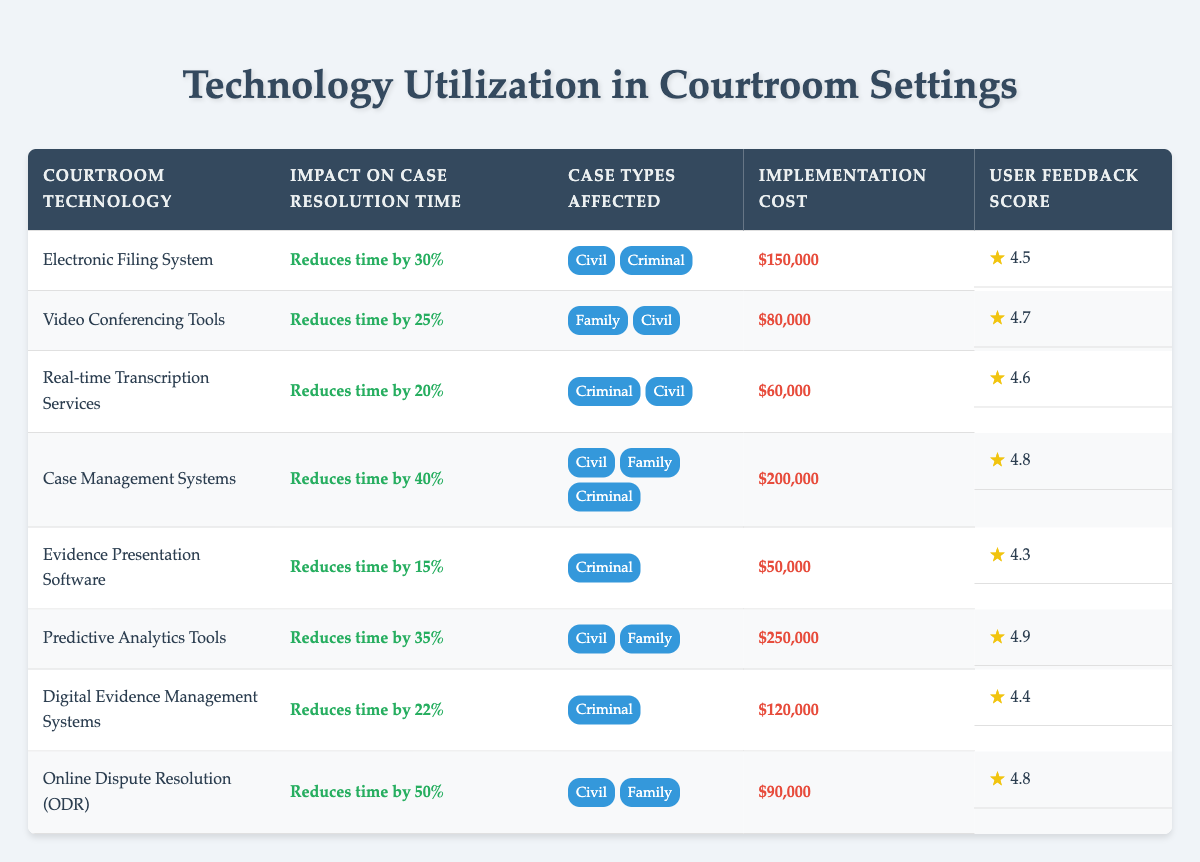What is the impact on case resolution time for the Case Management Systems? The table indicates that Case Management Systems reduce case resolution time by 40%. This information can be found in the column titled "Impact on Case Resolution Time" for the respective technology.
Answer: 40% Which courtroom technology has the highest user feedback score? By examining the "User Feedback Score" column, Predictive Analytics Tools has the highest score of 4.9. This is compared against all other technologies listed in the table to determine which one has the highest score.
Answer: 4.9 How much does it cost to implement the Evidence Presentation Software? The "Implementation Cost" column specifies that the cost to implement Evidence Presentation Software is $50,000, which is directly stated next to that technology in the table.
Answer: $50,000 Which case types are affected by the Online Dispute Resolution (ODR)? The table shows that Online Dispute Resolution (ODR) affects the case types Civil and Family. This can be referenced in the "Case Types Affected" column for that specific technology.
Answer: Civil, Family Is the implementation cost for Digital Evidence Management Systems greater than the average of all implementation costs? To find the average, sum the implementation costs of all technologies: $150,000 + $80,000 + $60,000 + $200,000 + $50,000 + $250,000 + $120,000 + $90,000 = $1,000,000. There are 8 technologies in total, so the average cost is $1,000,000 / 8 = $125,000. Since Digital Evidence Management Systems cost $120,000, which is less than the average of $125,000, the answer is no.
Answer: No Which two technologies together provide a reduction in case resolution time of over 60%? Looking at the impact reductions: Case Management Systems (40%) and Online Dispute Resolution (ODR) (50%) combine for a total of 90% reduction in case resolution time (40% + 50% = 90%). Since this exceeds 60%, these two technologies fulfill the criteria.
Answer: Case Management Systems and Online Dispute Resolution What is the total time reduction from using the Predictive Analytics Tools, Real-time Transcription Services, and Video Conferencing Tools? Summing the time reductions for these technologies: Predictive Analytics Tools (35%) + Real-time Transcription Services (20%) + Video Conferencing Tools (25%) equals 80% total time reduction (35% + 20% + 25% = 80%).
Answer: 80% Does the Evidence Presentation Software impact all case types? The "Case Types Affected" column shows that Evidence Presentation Software only impacts Criminal cases. Therefore, it does not affect all case types, making the answer no.
Answer: No What percentage of user feedback scores are above 4.5? Assessing the user feedback scores: 4.7, 4.6, 4.8, 4.9, 4.8 are above 4.5. Out of a total of 8 technologies, 5 have scores above 4.5. Thus, the percentage is (5/8) * 100 = 62.5%.
Answer: 62.5% 